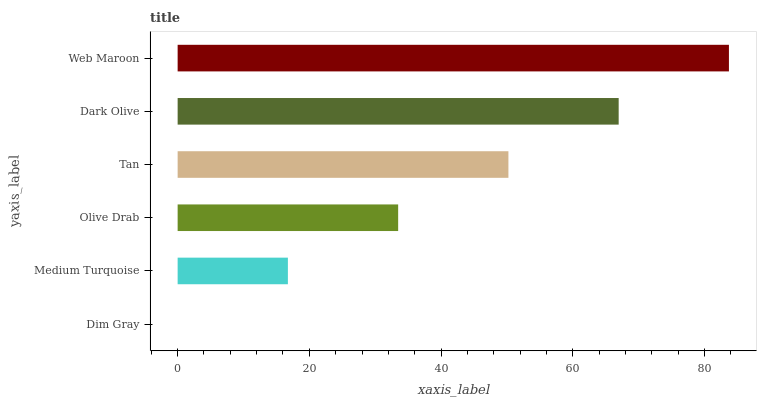Is Dim Gray the minimum?
Answer yes or no. Yes. Is Web Maroon the maximum?
Answer yes or no. Yes. Is Medium Turquoise the minimum?
Answer yes or no. No. Is Medium Turquoise the maximum?
Answer yes or no. No. Is Medium Turquoise greater than Dim Gray?
Answer yes or no. Yes. Is Dim Gray less than Medium Turquoise?
Answer yes or no. Yes. Is Dim Gray greater than Medium Turquoise?
Answer yes or no. No. Is Medium Turquoise less than Dim Gray?
Answer yes or no. No. Is Tan the high median?
Answer yes or no. Yes. Is Olive Drab the low median?
Answer yes or no. Yes. Is Olive Drab the high median?
Answer yes or no. No. Is Dim Gray the low median?
Answer yes or no. No. 